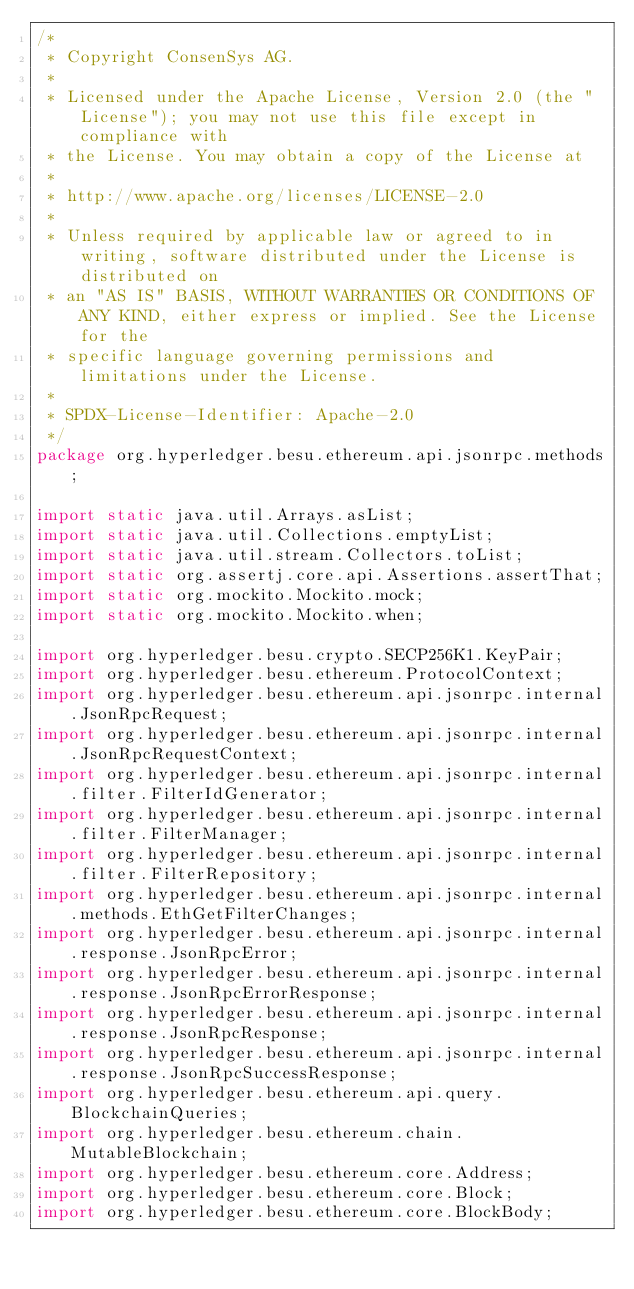Convert code to text. <code><loc_0><loc_0><loc_500><loc_500><_Java_>/*
 * Copyright ConsenSys AG.
 *
 * Licensed under the Apache License, Version 2.0 (the "License"); you may not use this file except in compliance with
 * the License. You may obtain a copy of the License at
 *
 * http://www.apache.org/licenses/LICENSE-2.0
 *
 * Unless required by applicable law or agreed to in writing, software distributed under the License is distributed on
 * an "AS IS" BASIS, WITHOUT WARRANTIES OR CONDITIONS OF ANY KIND, either express or implied. See the License for the
 * specific language governing permissions and limitations under the License.
 *
 * SPDX-License-Identifier: Apache-2.0
 */
package org.hyperledger.besu.ethereum.api.jsonrpc.methods;

import static java.util.Arrays.asList;
import static java.util.Collections.emptyList;
import static java.util.stream.Collectors.toList;
import static org.assertj.core.api.Assertions.assertThat;
import static org.mockito.Mockito.mock;
import static org.mockito.Mockito.when;

import org.hyperledger.besu.crypto.SECP256K1.KeyPair;
import org.hyperledger.besu.ethereum.ProtocolContext;
import org.hyperledger.besu.ethereum.api.jsonrpc.internal.JsonRpcRequest;
import org.hyperledger.besu.ethereum.api.jsonrpc.internal.JsonRpcRequestContext;
import org.hyperledger.besu.ethereum.api.jsonrpc.internal.filter.FilterIdGenerator;
import org.hyperledger.besu.ethereum.api.jsonrpc.internal.filter.FilterManager;
import org.hyperledger.besu.ethereum.api.jsonrpc.internal.filter.FilterRepository;
import org.hyperledger.besu.ethereum.api.jsonrpc.internal.methods.EthGetFilterChanges;
import org.hyperledger.besu.ethereum.api.jsonrpc.internal.response.JsonRpcError;
import org.hyperledger.besu.ethereum.api.jsonrpc.internal.response.JsonRpcErrorResponse;
import org.hyperledger.besu.ethereum.api.jsonrpc.internal.response.JsonRpcResponse;
import org.hyperledger.besu.ethereum.api.jsonrpc.internal.response.JsonRpcSuccessResponse;
import org.hyperledger.besu.ethereum.api.query.BlockchainQueries;
import org.hyperledger.besu.ethereum.chain.MutableBlockchain;
import org.hyperledger.besu.ethereum.core.Address;
import org.hyperledger.besu.ethereum.core.Block;
import org.hyperledger.besu.ethereum.core.BlockBody;</code> 